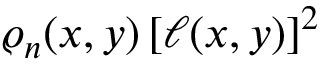<formula> <loc_0><loc_0><loc_500><loc_500>\varrho _ { n } ( x , y ) \, [ \ell ( x , y ) ] ^ { 2 }</formula> 